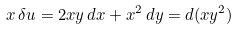<formula> <loc_0><loc_0><loc_500><loc_500>x \, \delta u = 2 x y \, d x + x ^ { 2 } \, d y = d ( x y ^ { 2 } )</formula> 